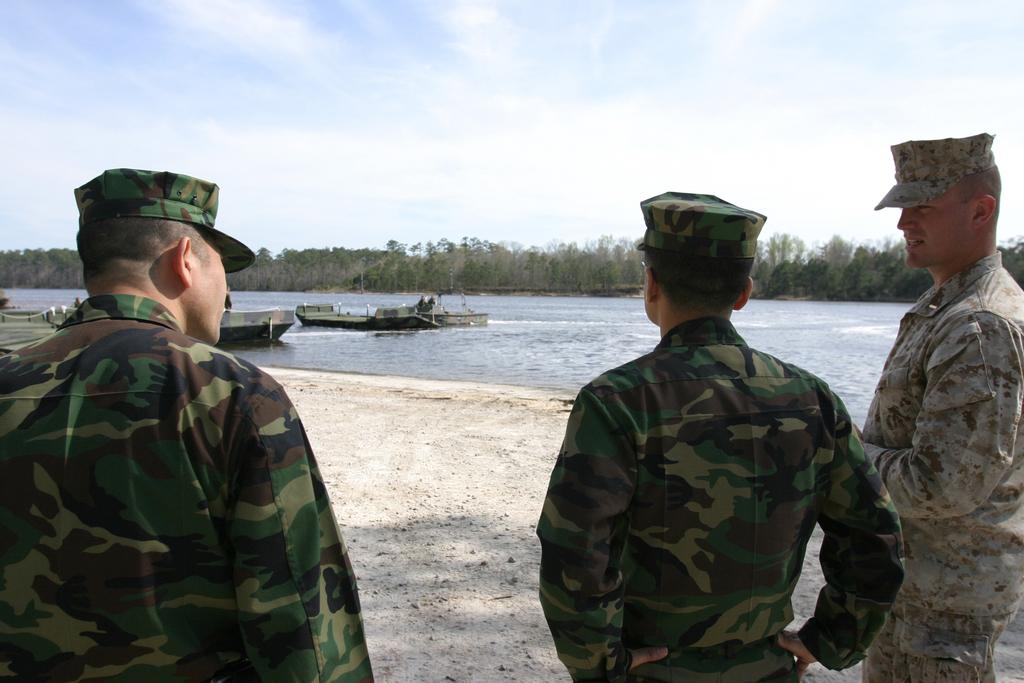What can be seen in the foreground of the image? There are persons standing in the front of the image. What is visible in the background of the image? There are boats on the water and trees in the background of the image. What is the condition of the sky in the image? The sky is cloudy in the image. Can you see any wishes being granted in the image? There are no wishes being granted in the image, as wishes are not a physical object that can be seen. Is there any flesh visible in the image? There is no flesh visible in the image, as the image does not depict any living beings or body parts. 